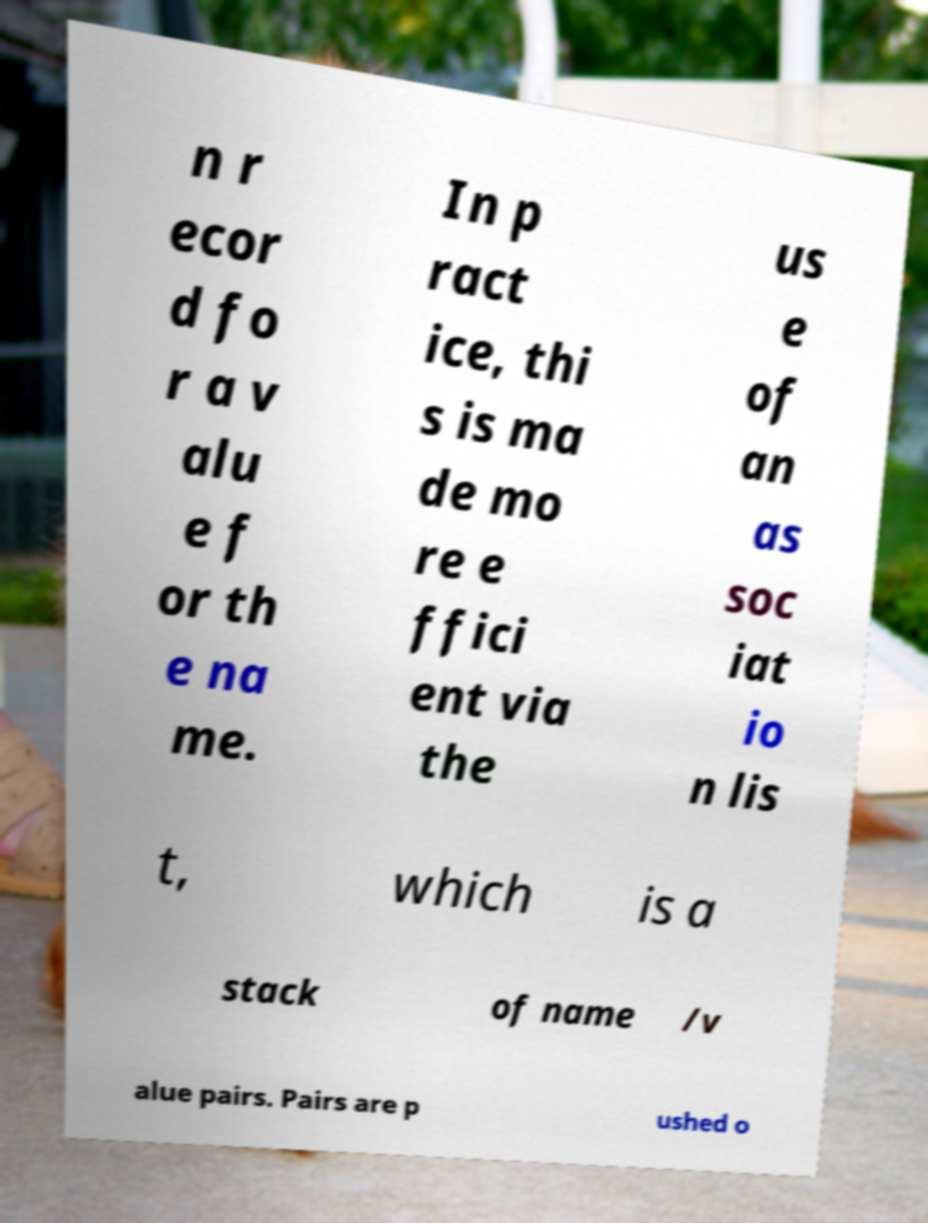Could you extract and type out the text from this image? n r ecor d fo r a v alu e f or th e na me. In p ract ice, thi s is ma de mo re e ffici ent via the us e of an as soc iat io n lis t, which is a stack of name /v alue pairs. Pairs are p ushed o 